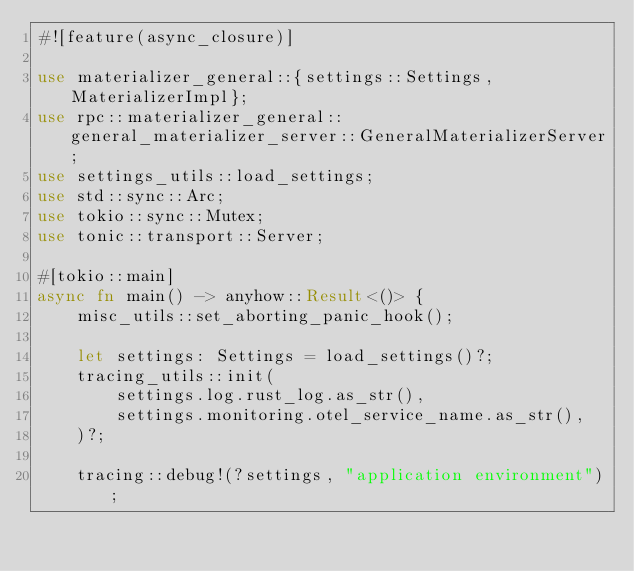Convert code to text. <code><loc_0><loc_0><loc_500><loc_500><_Rust_>#![feature(async_closure)]

use materializer_general::{settings::Settings, MaterializerImpl};
use rpc::materializer_general::general_materializer_server::GeneralMaterializerServer;
use settings_utils::load_settings;
use std::sync::Arc;
use tokio::sync::Mutex;
use tonic::transport::Server;

#[tokio::main]
async fn main() -> anyhow::Result<()> {
    misc_utils::set_aborting_panic_hook();

    let settings: Settings = load_settings()?;
    tracing_utils::init(
        settings.log.rust_log.as_str(),
        settings.monitoring.otel_service_name.as_str(),
    )?;

    tracing::debug!(?settings, "application environment");
</code> 